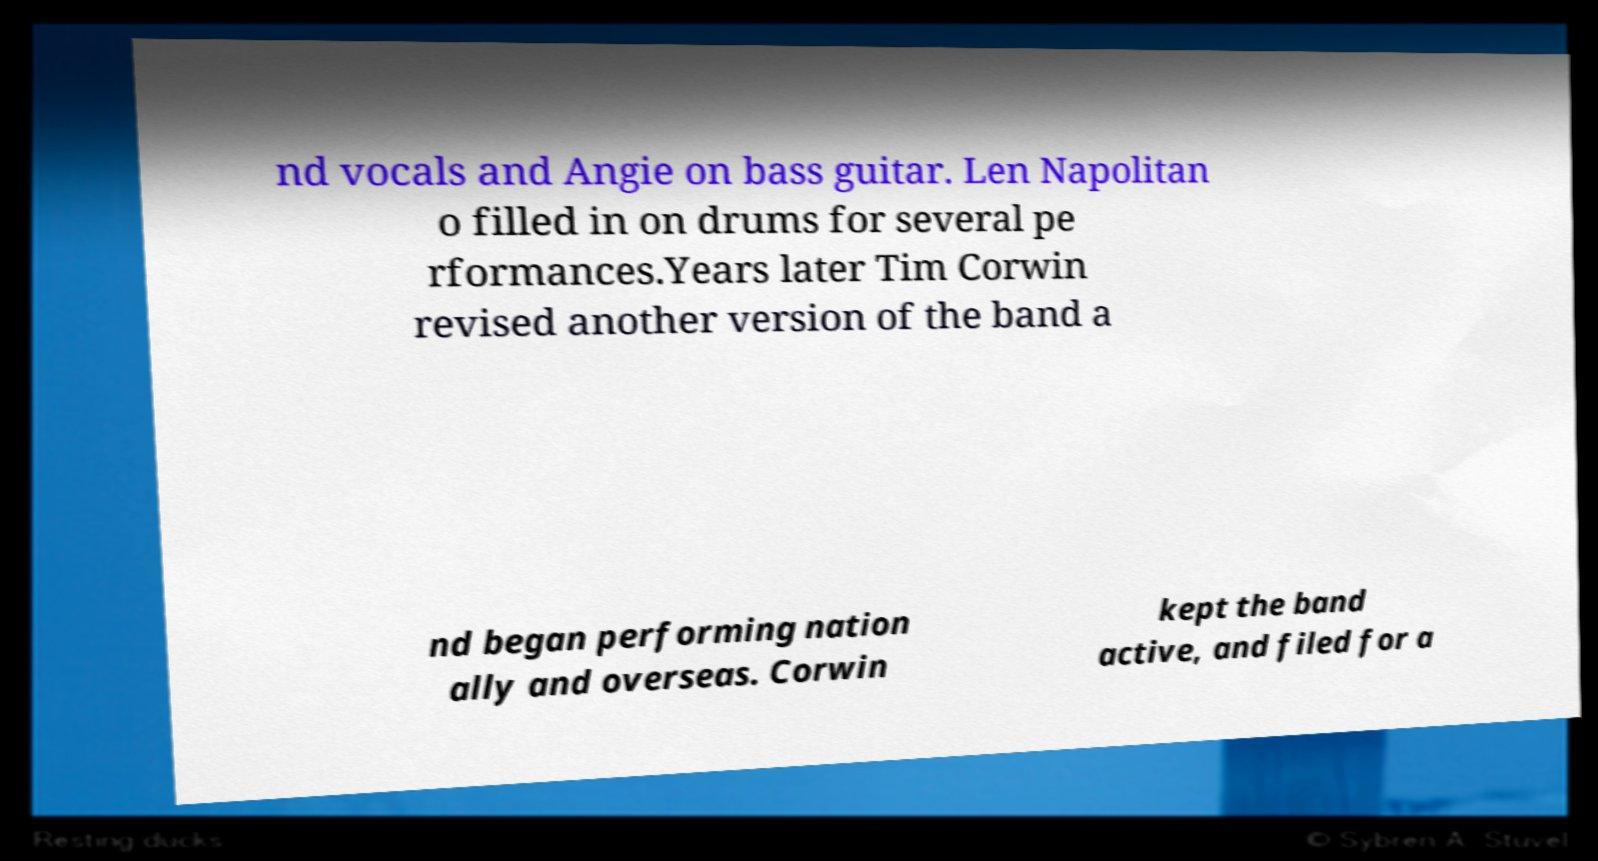Please identify and transcribe the text found in this image. nd vocals and Angie on bass guitar. Len Napolitan o filled in on drums for several pe rformances.Years later Tim Corwin revised another version of the band a nd began performing nation ally and overseas. Corwin kept the band active, and filed for a 